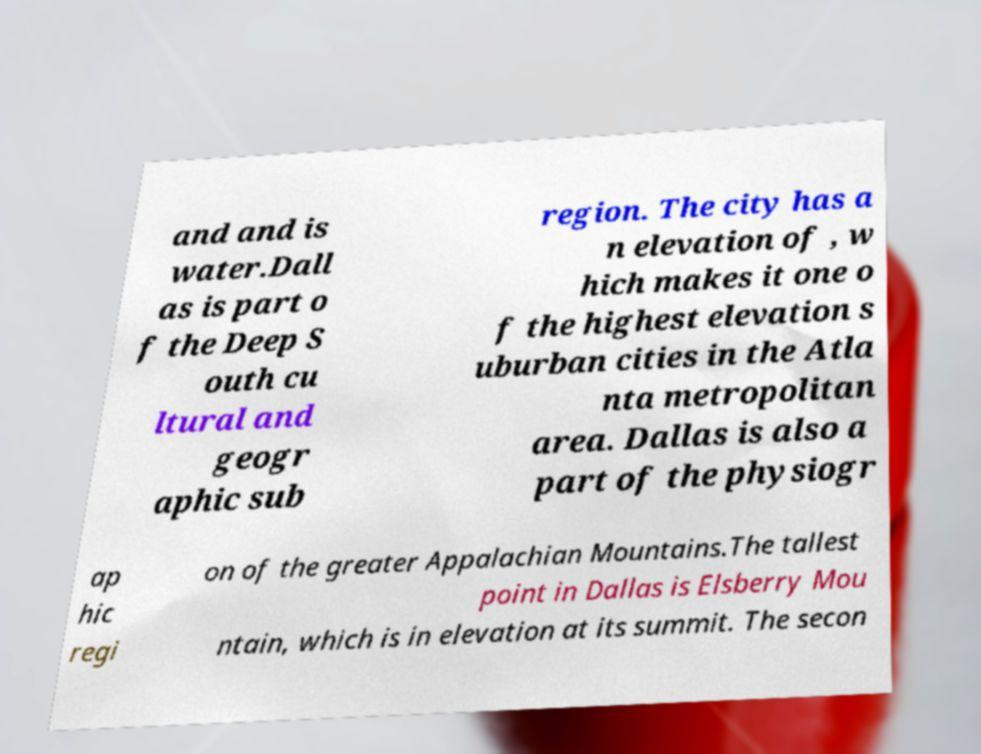Could you extract and type out the text from this image? and and is water.Dall as is part o f the Deep S outh cu ltural and geogr aphic sub region. The city has a n elevation of , w hich makes it one o f the highest elevation s uburban cities in the Atla nta metropolitan area. Dallas is also a part of the physiogr ap hic regi on of the greater Appalachian Mountains.The tallest point in Dallas is Elsberry Mou ntain, which is in elevation at its summit. The secon 